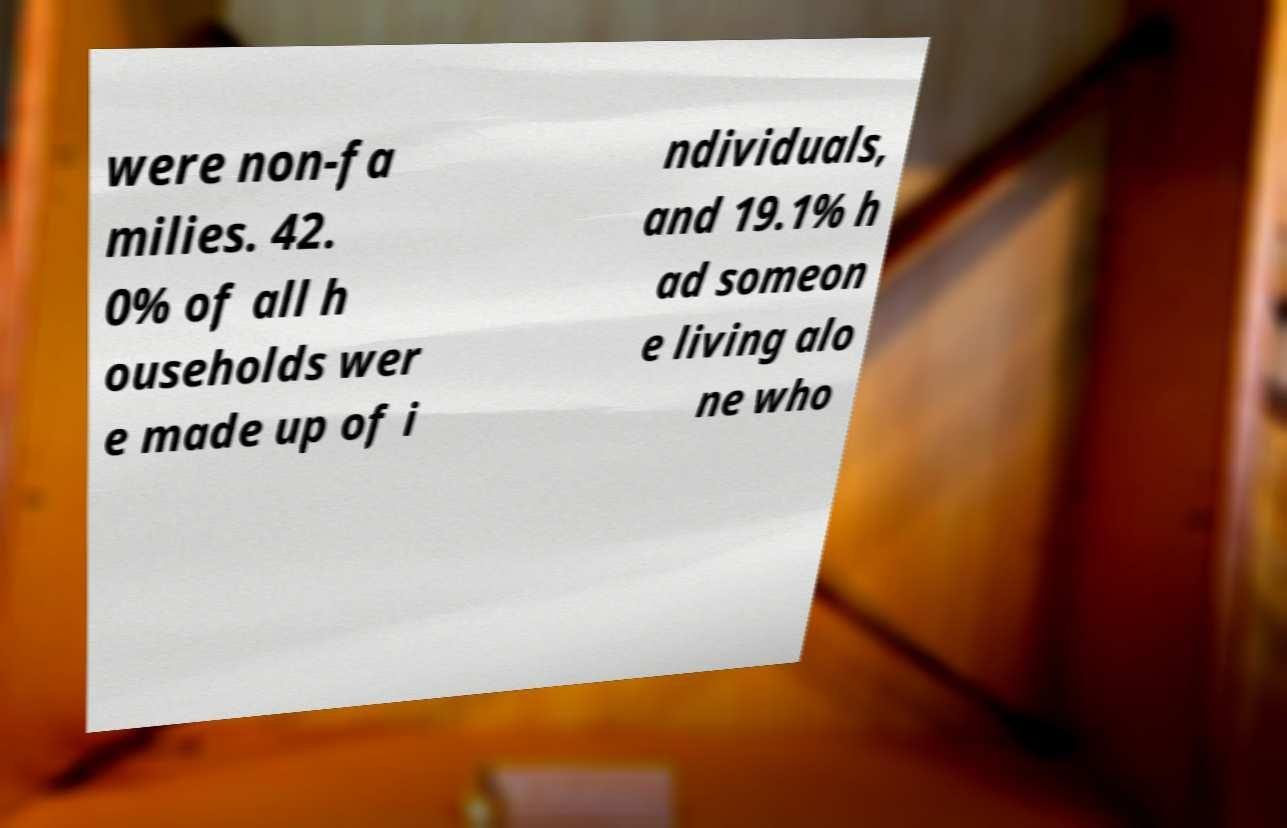For documentation purposes, I need the text within this image transcribed. Could you provide that? were non-fa milies. 42. 0% of all h ouseholds wer e made up of i ndividuals, and 19.1% h ad someon e living alo ne who 